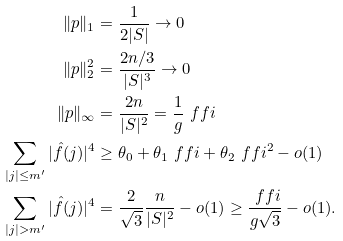Convert formula to latex. <formula><loc_0><loc_0><loc_500><loc_500>\| p \| _ { 1 } & = \frac { 1 } { 2 | S | } \to 0 \\ \| p \| _ { 2 } ^ { 2 } & = \frac { 2 n / 3 } { | S | ^ { 3 } } \to 0 \\ \| p \| _ { \infty } & = \frac { 2 n } { | S | ^ { 2 } } = \frac { 1 } { g } \ f f i \\ \sum _ { | j | \leq m ^ { \prime } } | \hat { f } ( j ) | ^ { 4 } & \geq \theta _ { 0 } + \theta _ { 1 } \ f f i + \theta _ { 2 } \ f f i ^ { 2 } - o ( 1 ) \\ \sum _ { | j | > m ^ { \prime } } | \hat { f } ( j ) | ^ { 4 } & = \frac { 2 } { \sqrt { 3 } } \frac { n } { | S | ^ { 2 } } - o ( 1 ) \geq \frac { \ f f i } { g \sqrt { 3 } } - o ( 1 ) .</formula> 